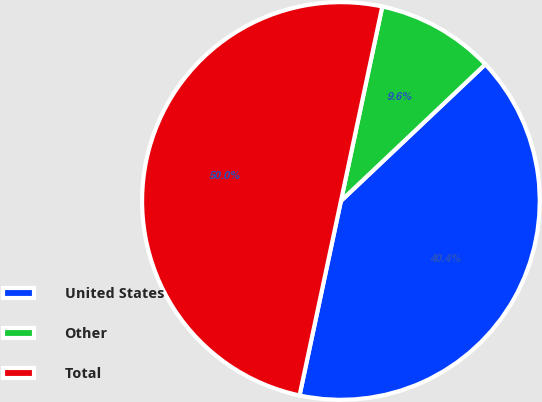<chart> <loc_0><loc_0><loc_500><loc_500><pie_chart><fcel>United States<fcel>Other<fcel>Total<nl><fcel>40.4%<fcel>9.6%<fcel>50.0%<nl></chart> 